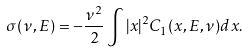<formula> <loc_0><loc_0><loc_500><loc_500>\sigma ( \nu , E ) = - \frac { \nu ^ { 2 } } { 2 } \int | x | ^ { 2 } C _ { 1 } ( x , E , \nu ) d x .</formula> 